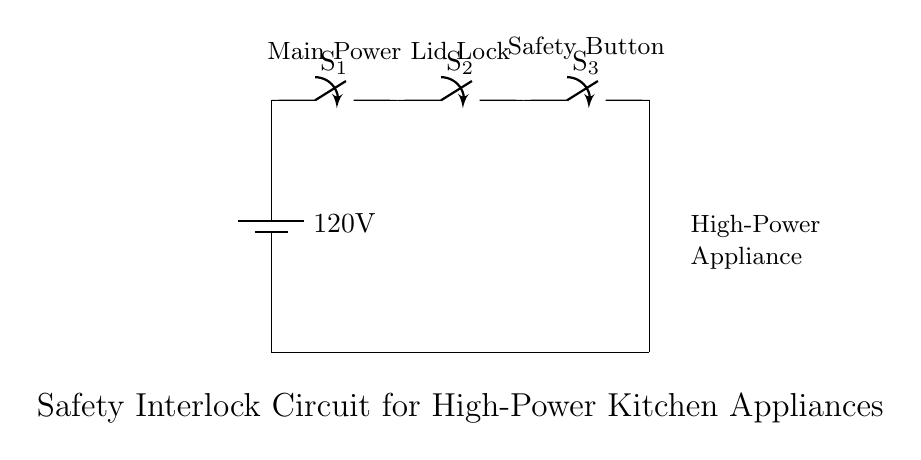What is the voltage of this circuit? The voltage is 120 volts, which is indicated by the battery symbol at the top of the circuit diagram.
Answer: 120 volts What is the purpose of switch S1? Switch S1 is the main power switch, used to control the supply of power to the entire circuit as it is connected directly to the battery.
Answer: Main power switch How many switches are used in this circuit? There are three switches used in the circuit: S1, S2, and S3. They are all positioned in series and serve different purposes in the safety interlock mechanism.
Answer: Three switches What happens if switch S2 is open? If switch S2 is open, it interrupts the circuit path, preventing current from flowing to the high-power appliance, which ensures that it cannot be activated accidentally.
Answer: Appliance cannot activate What is the function of the safety button S3? The safety button S3 allows for manual activation of the high-power appliance, but it only works if both S1 and S2 are closed, ensuring additional safety in operation.
Answer: Manual activation What is the connection type of the appliance in the circuit? The appliance is connected in series with the switches, meaning it requires all preceding switches to be closed for operation.
Answer: Series connection 